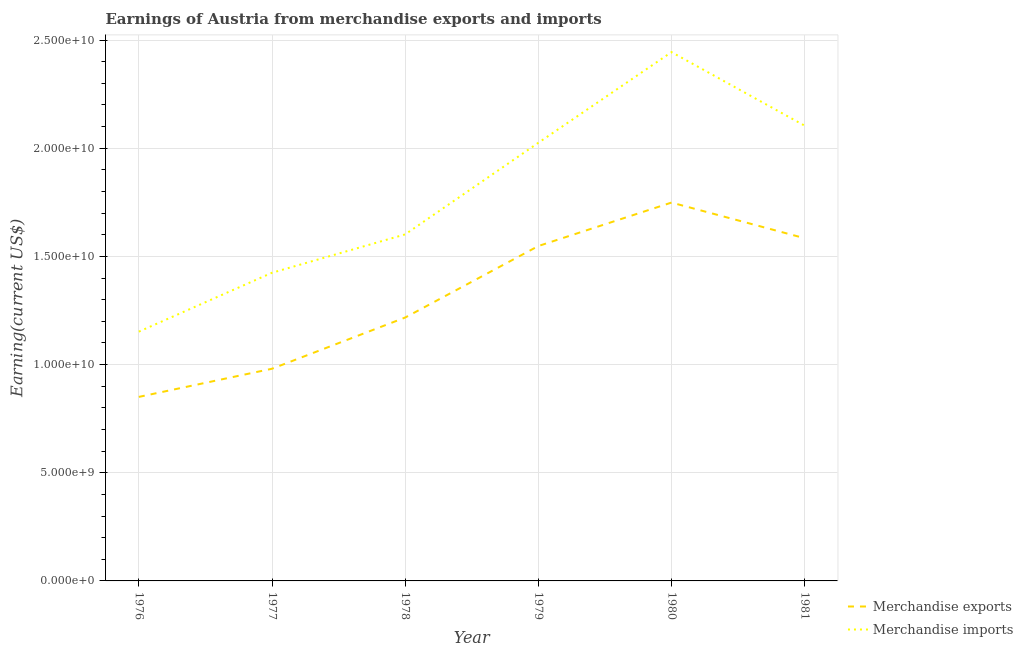How many different coloured lines are there?
Keep it short and to the point. 2. Does the line corresponding to earnings from merchandise exports intersect with the line corresponding to earnings from merchandise imports?
Ensure brevity in your answer.  No. Is the number of lines equal to the number of legend labels?
Your answer should be very brief. Yes. What is the earnings from merchandise imports in 1977?
Your response must be concise. 1.42e+1. Across all years, what is the maximum earnings from merchandise imports?
Offer a terse response. 2.44e+1. Across all years, what is the minimum earnings from merchandise exports?
Your answer should be compact. 8.51e+09. In which year was the earnings from merchandise exports minimum?
Ensure brevity in your answer.  1976. What is the total earnings from merchandise imports in the graph?
Your answer should be compact. 1.08e+11. What is the difference between the earnings from merchandise exports in 1977 and that in 1979?
Keep it short and to the point. -5.67e+09. What is the difference between the earnings from merchandise imports in 1977 and the earnings from merchandise exports in 1981?
Offer a very short reply. -1.60e+09. What is the average earnings from merchandise imports per year?
Provide a short and direct response. 1.79e+1. In the year 1981, what is the difference between the earnings from merchandise exports and earnings from merchandise imports?
Give a very brief answer. -5.20e+09. What is the ratio of the earnings from merchandise imports in 1976 to that in 1981?
Give a very brief answer. 0.55. Is the difference between the earnings from merchandise exports in 1979 and 1981 greater than the difference between the earnings from merchandise imports in 1979 and 1981?
Make the answer very short. Yes. What is the difference between the highest and the second highest earnings from merchandise exports?
Provide a short and direct response. 1.65e+09. What is the difference between the highest and the lowest earnings from merchandise exports?
Ensure brevity in your answer.  8.98e+09. Is the sum of the earnings from merchandise exports in 1977 and 1981 greater than the maximum earnings from merchandise imports across all years?
Offer a terse response. Yes. Does the earnings from merchandise imports monotonically increase over the years?
Your answer should be very brief. No. Does the graph contain grids?
Make the answer very short. Yes. What is the title of the graph?
Your answer should be very brief. Earnings of Austria from merchandise exports and imports. What is the label or title of the Y-axis?
Keep it short and to the point. Earning(current US$). What is the Earning(current US$) in Merchandise exports in 1976?
Give a very brief answer. 8.51e+09. What is the Earning(current US$) of Merchandise imports in 1976?
Provide a succinct answer. 1.15e+1. What is the Earning(current US$) of Merchandise exports in 1977?
Provide a short and direct response. 9.81e+09. What is the Earning(current US$) in Merchandise imports in 1977?
Provide a short and direct response. 1.42e+1. What is the Earning(current US$) in Merchandise exports in 1978?
Give a very brief answer. 1.22e+1. What is the Earning(current US$) in Merchandise imports in 1978?
Your response must be concise. 1.60e+1. What is the Earning(current US$) in Merchandise exports in 1979?
Keep it short and to the point. 1.55e+1. What is the Earning(current US$) of Merchandise imports in 1979?
Ensure brevity in your answer.  2.03e+1. What is the Earning(current US$) in Merchandise exports in 1980?
Offer a very short reply. 1.75e+1. What is the Earning(current US$) in Merchandise imports in 1980?
Offer a terse response. 2.44e+1. What is the Earning(current US$) in Merchandise exports in 1981?
Your answer should be compact. 1.58e+1. What is the Earning(current US$) in Merchandise imports in 1981?
Give a very brief answer. 2.10e+1. Across all years, what is the maximum Earning(current US$) of Merchandise exports?
Provide a succinct answer. 1.75e+1. Across all years, what is the maximum Earning(current US$) of Merchandise imports?
Keep it short and to the point. 2.44e+1. Across all years, what is the minimum Earning(current US$) of Merchandise exports?
Give a very brief answer. 8.51e+09. Across all years, what is the minimum Earning(current US$) in Merchandise imports?
Provide a short and direct response. 1.15e+1. What is the total Earning(current US$) in Merchandise exports in the graph?
Provide a succinct answer. 7.93e+1. What is the total Earning(current US$) of Merchandise imports in the graph?
Make the answer very short. 1.08e+11. What is the difference between the Earning(current US$) of Merchandise exports in 1976 and that in 1977?
Offer a terse response. -1.30e+09. What is the difference between the Earning(current US$) of Merchandise imports in 1976 and that in 1977?
Provide a short and direct response. -2.72e+09. What is the difference between the Earning(current US$) of Merchandise exports in 1976 and that in 1978?
Offer a terse response. -3.67e+09. What is the difference between the Earning(current US$) in Merchandise imports in 1976 and that in 1978?
Provide a succinct answer. -4.50e+09. What is the difference between the Earning(current US$) of Merchandise exports in 1976 and that in 1979?
Your answer should be very brief. -6.97e+09. What is the difference between the Earning(current US$) of Merchandise imports in 1976 and that in 1979?
Your answer should be compact. -8.73e+09. What is the difference between the Earning(current US$) of Merchandise exports in 1976 and that in 1980?
Provide a short and direct response. -8.98e+09. What is the difference between the Earning(current US$) in Merchandise imports in 1976 and that in 1980?
Keep it short and to the point. -1.29e+1. What is the difference between the Earning(current US$) of Merchandise exports in 1976 and that in 1981?
Ensure brevity in your answer.  -7.33e+09. What is the difference between the Earning(current US$) of Merchandise imports in 1976 and that in 1981?
Provide a short and direct response. -9.52e+09. What is the difference between the Earning(current US$) of Merchandise exports in 1977 and that in 1978?
Make the answer very short. -2.37e+09. What is the difference between the Earning(current US$) in Merchandise imports in 1977 and that in 1978?
Provide a short and direct response. -1.77e+09. What is the difference between the Earning(current US$) in Merchandise exports in 1977 and that in 1979?
Your response must be concise. -5.67e+09. What is the difference between the Earning(current US$) of Merchandise imports in 1977 and that in 1979?
Give a very brief answer. -6.01e+09. What is the difference between the Earning(current US$) of Merchandise exports in 1977 and that in 1980?
Offer a terse response. -7.68e+09. What is the difference between the Earning(current US$) of Merchandise imports in 1977 and that in 1980?
Your answer should be very brief. -1.02e+1. What is the difference between the Earning(current US$) of Merchandise exports in 1977 and that in 1981?
Ensure brevity in your answer.  -6.03e+09. What is the difference between the Earning(current US$) of Merchandise imports in 1977 and that in 1981?
Your answer should be very brief. -6.80e+09. What is the difference between the Earning(current US$) of Merchandise exports in 1978 and that in 1979?
Keep it short and to the point. -3.31e+09. What is the difference between the Earning(current US$) in Merchandise imports in 1978 and that in 1979?
Offer a terse response. -4.23e+09. What is the difference between the Earning(current US$) in Merchandise exports in 1978 and that in 1980?
Offer a very short reply. -5.31e+09. What is the difference between the Earning(current US$) in Merchandise imports in 1978 and that in 1980?
Your response must be concise. -8.43e+09. What is the difference between the Earning(current US$) in Merchandise exports in 1978 and that in 1981?
Ensure brevity in your answer.  -3.67e+09. What is the difference between the Earning(current US$) in Merchandise imports in 1978 and that in 1981?
Give a very brief answer. -5.02e+09. What is the difference between the Earning(current US$) in Merchandise exports in 1979 and that in 1980?
Your answer should be compact. -2.01e+09. What is the difference between the Earning(current US$) of Merchandise imports in 1979 and that in 1980?
Your answer should be compact. -4.19e+09. What is the difference between the Earning(current US$) in Merchandise exports in 1979 and that in 1981?
Your response must be concise. -3.60e+08. What is the difference between the Earning(current US$) of Merchandise imports in 1979 and that in 1981?
Make the answer very short. -7.91e+08. What is the difference between the Earning(current US$) in Merchandise exports in 1980 and that in 1981?
Your answer should be compact. 1.65e+09. What is the difference between the Earning(current US$) of Merchandise imports in 1980 and that in 1981?
Give a very brief answer. 3.40e+09. What is the difference between the Earning(current US$) in Merchandise exports in 1976 and the Earning(current US$) in Merchandise imports in 1977?
Provide a succinct answer. -5.74e+09. What is the difference between the Earning(current US$) of Merchandise exports in 1976 and the Earning(current US$) of Merchandise imports in 1978?
Make the answer very short. -7.51e+09. What is the difference between the Earning(current US$) of Merchandise exports in 1976 and the Earning(current US$) of Merchandise imports in 1979?
Your answer should be very brief. -1.17e+1. What is the difference between the Earning(current US$) of Merchandise exports in 1976 and the Earning(current US$) of Merchandise imports in 1980?
Provide a succinct answer. -1.59e+1. What is the difference between the Earning(current US$) of Merchandise exports in 1976 and the Earning(current US$) of Merchandise imports in 1981?
Keep it short and to the point. -1.25e+1. What is the difference between the Earning(current US$) of Merchandise exports in 1977 and the Earning(current US$) of Merchandise imports in 1978?
Give a very brief answer. -6.21e+09. What is the difference between the Earning(current US$) in Merchandise exports in 1977 and the Earning(current US$) in Merchandise imports in 1979?
Your answer should be very brief. -1.04e+1. What is the difference between the Earning(current US$) in Merchandise exports in 1977 and the Earning(current US$) in Merchandise imports in 1980?
Your answer should be very brief. -1.46e+1. What is the difference between the Earning(current US$) of Merchandise exports in 1977 and the Earning(current US$) of Merchandise imports in 1981?
Make the answer very short. -1.12e+1. What is the difference between the Earning(current US$) of Merchandise exports in 1978 and the Earning(current US$) of Merchandise imports in 1979?
Offer a very short reply. -8.08e+09. What is the difference between the Earning(current US$) in Merchandise exports in 1978 and the Earning(current US$) in Merchandise imports in 1980?
Your answer should be compact. -1.23e+1. What is the difference between the Earning(current US$) of Merchandise exports in 1978 and the Earning(current US$) of Merchandise imports in 1981?
Provide a succinct answer. -8.87e+09. What is the difference between the Earning(current US$) in Merchandise exports in 1979 and the Earning(current US$) in Merchandise imports in 1980?
Keep it short and to the point. -8.96e+09. What is the difference between the Earning(current US$) in Merchandise exports in 1979 and the Earning(current US$) in Merchandise imports in 1981?
Provide a short and direct response. -5.56e+09. What is the difference between the Earning(current US$) of Merchandise exports in 1980 and the Earning(current US$) of Merchandise imports in 1981?
Make the answer very short. -3.55e+09. What is the average Earning(current US$) of Merchandise exports per year?
Give a very brief answer. 1.32e+1. What is the average Earning(current US$) in Merchandise imports per year?
Offer a very short reply. 1.79e+1. In the year 1976, what is the difference between the Earning(current US$) of Merchandise exports and Earning(current US$) of Merchandise imports?
Your response must be concise. -3.02e+09. In the year 1977, what is the difference between the Earning(current US$) in Merchandise exports and Earning(current US$) in Merchandise imports?
Keep it short and to the point. -4.44e+09. In the year 1978, what is the difference between the Earning(current US$) of Merchandise exports and Earning(current US$) of Merchandise imports?
Provide a short and direct response. -3.84e+09. In the year 1979, what is the difference between the Earning(current US$) of Merchandise exports and Earning(current US$) of Merchandise imports?
Offer a very short reply. -4.77e+09. In the year 1980, what is the difference between the Earning(current US$) of Merchandise exports and Earning(current US$) of Merchandise imports?
Offer a very short reply. -6.96e+09. In the year 1981, what is the difference between the Earning(current US$) in Merchandise exports and Earning(current US$) in Merchandise imports?
Make the answer very short. -5.20e+09. What is the ratio of the Earning(current US$) of Merchandise exports in 1976 to that in 1977?
Provide a succinct answer. 0.87. What is the ratio of the Earning(current US$) of Merchandise imports in 1976 to that in 1977?
Your response must be concise. 0.81. What is the ratio of the Earning(current US$) in Merchandise exports in 1976 to that in 1978?
Make the answer very short. 0.7. What is the ratio of the Earning(current US$) in Merchandise imports in 1976 to that in 1978?
Your response must be concise. 0.72. What is the ratio of the Earning(current US$) of Merchandise exports in 1976 to that in 1979?
Offer a terse response. 0.55. What is the ratio of the Earning(current US$) in Merchandise imports in 1976 to that in 1979?
Make the answer very short. 0.57. What is the ratio of the Earning(current US$) of Merchandise exports in 1976 to that in 1980?
Offer a very short reply. 0.49. What is the ratio of the Earning(current US$) in Merchandise imports in 1976 to that in 1980?
Give a very brief answer. 0.47. What is the ratio of the Earning(current US$) of Merchandise exports in 1976 to that in 1981?
Offer a terse response. 0.54. What is the ratio of the Earning(current US$) in Merchandise imports in 1976 to that in 1981?
Offer a very short reply. 0.55. What is the ratio of the Earning(current US$) in Merchandise exports in 1977 to that in 1978?
Provide a succinct answer. 0.81. What is the ratio of the Earning(current US$) in Merchandise imports in 1977 to that in 1978?
Offer a terse response. 0.89. What is the ratio of the Earning(current US$) of Merchandise exports in 1977 to that in 1979?
Offer a terse response. 0.63. What is the ratio of the Earning(current US$) of Merchandise imports in 1977 to that in 1979?
Provide a short and direct response. 0.7. What is the ratio of the Earning(current US$) of Merchandise exports in 1977 to that in 1980?
Provide a short and direct response. 0.56. What is the ratio of the Earning(current US$) of Merchandise imports in 1977 to that in 1980?
Make the answer very short. 0.58. What is the ratio of the Earning(current US$) of Merchandise exports in 1977 to that in 1981?
Provide a succinct answer. 0.62. What is the ratio of the Earning(current US$) in Merchandise imports in 1977 to that in 1981?
Offer a terse response. 0.68. What is the ratio of the Earning(current US$) in Merchandise exports in 1978 to that in 1979?
Offer a very short reply. 0.79. What is the ratio of the Earning(current US$) in Merchandise imports in 1978 to that in 1979?
Offer a very short reply. 0.79. What is the ratio of the Earning(current US$) of Merchandise exports in 1978 to that in 1980?
Keep it short and to the point. 0.7. What is the ratio of the Earning(current US$) in Merchandise imports in 1978 to that in 1980?
Your answer should be very brief. 0.66. What is the ratio of the Earning(current US$) in Merchandise exports in 1978 to that in 1981?
Ensure brevity in your answer.  0.77. What is the ratio of the Earning(current US$) in Merchandise imports in 1978 to that in 1981?
Offer a terse response. 0.76. What is the ratio of the Earning(current US$) in Merchandise exports in 1979 to that in 1980?
Provide a short and direct response. 0.89. What is the ratio of the Earning(current US$) of Merchandise imports in 1979 to that in 1980?
Offer a very short reply. 0.83. What is the ratio of the Earning(current US$) of Merchandise exports in 1979 to that in 1981?
Offer a terse response. 0.98. What is the ratio of the Earning(current US$) in Merchandise imports in 1979 to that in 1981?
Your answer should be very brief. 0.96. What is the ratio of the Earning(current US$) of Merchandise exports in 1980 to that in 1981?
Provide a short and direct response. 1.1. What is the ratio of the Earning(current US$) of Merchandise imports in 1980 to that in 1981?
Provide a short and direct response. 1.16. What is the difference between the highest and the second highest Earning(current US$) of Merchandise exports?
Provide a succinct answer. 1.65e+09. What is the difference between the highest and the second highest Earning(current US$) in Merchandise imports?
Ensure brevity in your answer.  3.40e+09. What is the difference between the highest and the lowest Earning(current US$) of Merchandise exports?
Keep it short and to the point. 8.98e+09. What is the difference between the highest and the lowest Earning(current US$) of Merchandise imports?
Give a very brief answer. 1.29e+1. 